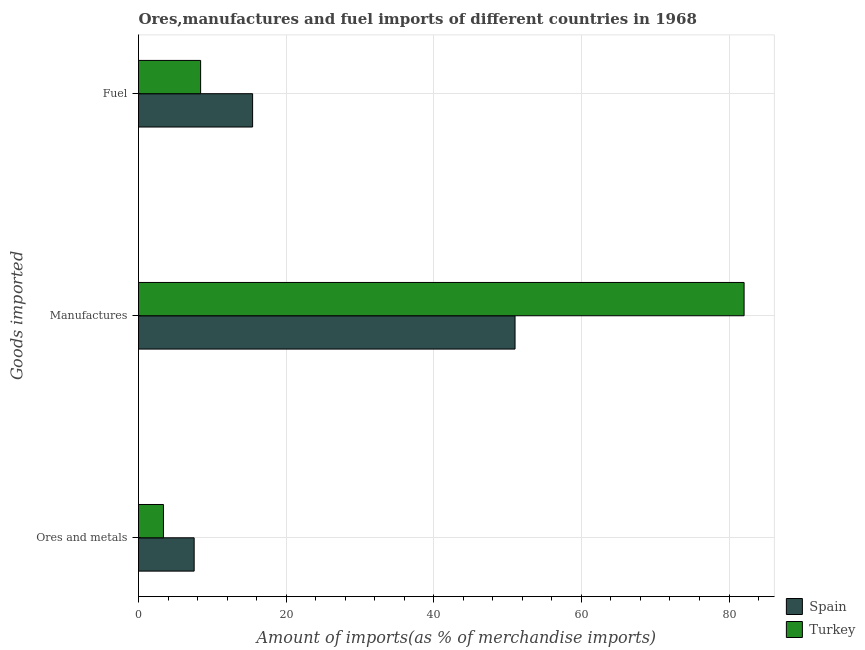Are the number of bars on each tick of the Y-axis equal?
Your answer should be compact. Yes. What is the label of the 2nd group of bars from the top?
Offer a very short reply. Manufactures. What is the percentage of ores and metals imports in Turkey?
Your response must be concise. 3.38. Across all countries, what is the maximum percentage of ores and metals imports?
Provide a short and direct response. 7.54. Across all countries, what is the minimum percentage of manufactures imports?
Provide a short and direct response. 51.01. In which country was the percentage of ores and metals imports maximum?
Make the answer very short. Spain. What is the total percentage of ores and metals imports in the graph?
Ensure brevity in your answer.  10.92. What is the difference between the percentage of manufactures imports in Spain and that in Turkey?
Your answer should be compact. -31.03. What is the difference between the percentage of manufactures imports in Spain and the percentage of fuel imports in Turkey?
Offer a terse response. 42.6. What is the average percentage of fuel imports per country?
Your answer should be very brief. 11.94. What is the difference between the percentage of ores and metals imports and percentage of fuel imports in Spain?
Your answer should be very brief. -7.92. In how many countries, is the percentage of ores and metals imports greater than 16 %?
Offer a very short reply. 0. What is the ratio of the percentage of manufactures imports in Turkey to that in Spain?
Your answer should be very brief. 1.61. Is the difference between the percentage of fuel imports in Turkey and Spain greater than the difference between the percentage of ores and metals imports in Turkey and Spain?
Keep it short and to the point. No. What is the difference between the highest and the second highest percentage of fuel imports?
Keep it short and to the point. 7.04. What is the difference between the highest and the lowest percentage of manufactures imports?
Your answer should be very brief. 31.03. Is it the case that in every country, the sum of the percentage of ores and metals imports and percentage of manufactures imports is greater than the percentage of fuel imports?
Your response must be concise. Yes. How many bars are there?
Offer a very short reply. 6. Are all the bars in the graph horizontal?
Ensure brevity in your answer.  Yes. Are the values on the major ticks of X-axis written in scientific E-notation?
Ensure brevity in your answer.  No. Where does the legend appear in the graph?
Offer a very short reply. Bottom right. How many legend labels are there?
Make the answer very short. 2. How are the legend labels stacked?
Offer a very short reply. Vertical. What is the title of the graph?
Keep it short and to the point. Ores,manufactures and fuel imports of different countries in 1968. Does "Nicaragua" appear as one of the legend labels in the graph?
Keep it short and to the point. No. What is the label or title of the X-axis?
Your answer should be compact. Amount of imports(as % of merchandise imports). What is the label or title of the Y-axis?
Your answer should be compact. Goods imported. What is the Amount of imports(as % of merchandise imports) in Spain in Ores and metals?
Offer a terse response. 7.54. What is the Amount of imports(as % of merchandise imports) of Turkey in Ores and metals?
Your answer should be very brief. 3.38. What is the Amount of imports(as % of merchandise imports) in Spain in Manufactures?
Offer a terse response. 51.01. What is the Amount of imports(as % of merchandise imports) of Turkey in Manufactures?
Your answer should be compact. 82.05. What is the Amount of imports(as % of merchandise imports) in Spain in Fuel?
Your answer should be very brief. 15.46. What is the Amount of imports(as % of merchandise imports) in Turkey in Fuel?
Your answer should be very brief. 8.42. Across all Goods imported, what is the maximum Amount of imports(as % of merchandise imports) in Spain?
Your response must be concise. 51.01. Across all Goods imported, what is the maximum Amount of imports(as % of merchandise imports) of Turkey?
Make the answer very short. 82.05. Across all Goods imported, what is the minimum Amount of imports(as % of merchandise imports) of Spain?
Offer a terse response. 7.54. Across all Goods imported, what is the minimum Amount of imports(as % of merchandise imports) of Turkey?
Offer a terse response. 3.38. What is the total Amount of imports(as % of merchandise imports) in Spain in the graph?
Give a very brief answer. 74.01. What is the total Amount of imports(as % of merchandise imports) of Turkey in the graph?
Provide a short and direct response. 93.84. What is the difference between the Amount of imports(as % of merchandise imports) of Spain in Ores and metals and that in Manufactures?
Make the answer very short. -43.47. What is the difference between the Amount of imports(as % of merchandise imports) of Turkey in Ores and metals and that in Manufactures?
Offer a terse response. -78.66. What is the difference between the Amount of imports(as % of merchandise imports) of Spain in Ores and metals and that in Fuel?
Your answer should be very brief. -7.92. What is the difference between the Amount of imports(as % of merchandise imports) of Turkey in Ores and metals and that in Fuel?
Provide a short and direct response. -5.04. What is the difference between the Amount of imports(as % of merchandise imports) in Spain in Manufactures and that in Fuel?
Your answer should be compact. 35.55. What is the difference between the Amount of imports(as % of merchandise imports) of Turkey in Manufactures and that in Fuel?
Provide a succinct answer. 73.63. What is the difference between the Amount of imports(as % of merchandise imports) in Spain in Ores and metals and the Amount of imports(as % of merchandise imports) in Turkey in Manufactures?
Ensure brevity in your answer.  -74.51. What is the difference between the Amount of imports(as % of merchandise imports) of Spain in Ores and metals and the Amount of imports(as % of merchandise imports) of Turkey in Fuel?
Your answer should be very brief. -0.88. What is the difference between the Amount of imports(as % of merchandise imports) in Spain in Manufactures and the Amount of imports(as % of merchandise imports) in Turkey in Fuel?
Your response must be concise. 42.6. What is the average Amount of imports(as % of merchandise imports) of Spain per Goods imported?
Provide a succinct answer. 24.67. What is the average Amount of imports(as % of merchandise imports) in Turkey per Goods imported?
Offer a terse response. 31.28. What is the difference between the Amount of imports(as % of merchandise imports) of Spain and Amount of imports(as % of merchandise imports) of Turkey in Ores and metals?
Give a very brief answer. 4.16. What is the difference between the Amount of imports(as % of merchandise imports) in Spain and Amount of imports(as % of merchandise imports) in Turkey in Manufactures?
Provide a succinct answer. -31.03. What is the difference between the Amount of imports(as % of merchandise imports) in Spain and Amount of imports(as % of merchandise imports) in Turkey in Fuel?
Provide a short and direct response. 7.04. What is the ratio of the Amount of imports(as % of merchandise imports) of Spain in Ores and metals to that in Manufactures?
Make the answer very short. 0.15. What is the ratio of the Amount of imports(as % of merchandise imports) in Turkey in Ores and metals to that in Manufactures?
Provide a short and direct response. 0.04. What is the ratio of the Amount of imports(as % of merchandise imports) in Spain in Ores and metals to that in Fuel?
Offer a very short reply. 0.49. What is the ratio of the Amount of imports(as % of merchandise imports) of Turkey in Ores and metals to that in Fuel?
Provide a succinct answer. 0.4. What is the ratio of the Amount of imports(as % of merchandise imports) of Spain in Manufactures to that in Fuel?
Keep it short and to the point. 3.3. What is the ratio of the Amount of imports(as % of merchandise imports) in Turkey in Manufactures to that in Fuel?
Give a very brief answer. 9.75. What is the difference between the highest and the second highest Amount of imports(as % of merchandise imports) in Spain?
Your answer should be very brief. 35.55. What is the difference between the highest and the second highest Amount of imports(as % of merchandise imports) of Turkey?
Make the answer very short. 73.63. What is the difference between the highest and the lowest Amount of imports(as % of merchandise imports) in Spain?
Give a very brief answer. 43.47. What is the difference between the highest and the lowest Amount of imports(as % of merchandise imports) in Turkey?
Provide a short and direct response. 78.66. 